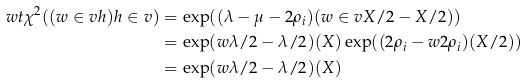<formula> <loc_0><loc_0><loc_500><loc_500>\ w t \chi ^ { 2 } ( ( w \in v h ) h \in v ) & = \exp ( ( \lambda - \mu - 2 \rho _ { i } ) ( w \in v X / 2 - X / 2 ) ) \\ & = \exp ( w \lambda / 2 - \lambda / 2 ) ( X ) \exp ( ( 2 \rho _ { i } - w 2 \rho _ { i } ) ( X / 2 ) ) \\ & = \exp ( w \lambda / 2 - \lambda / 2 ) ( X )</formula> 